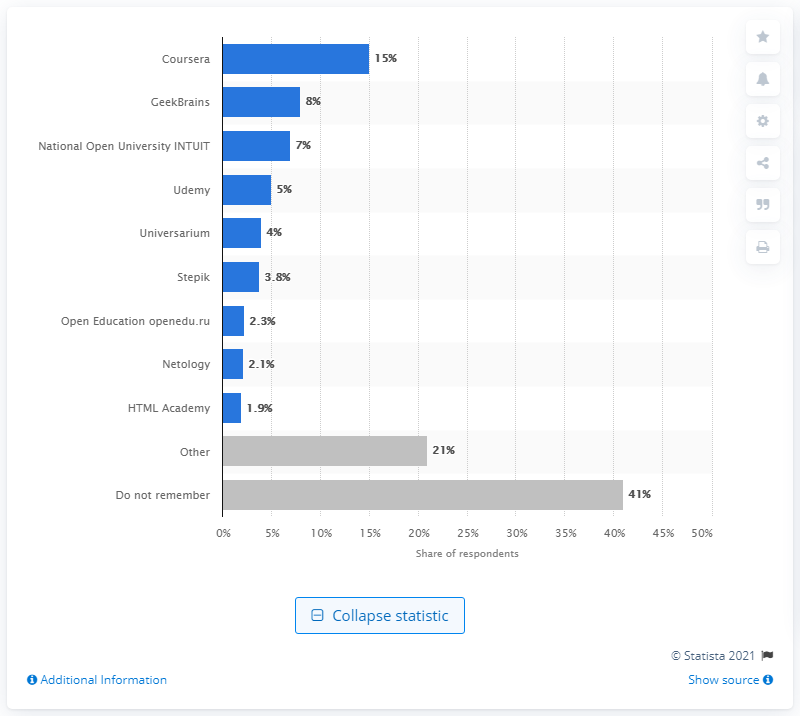Give some essential details in this illustration. According to data from the Russian market, Coursera is the most popular digital learning platform among Russians. 